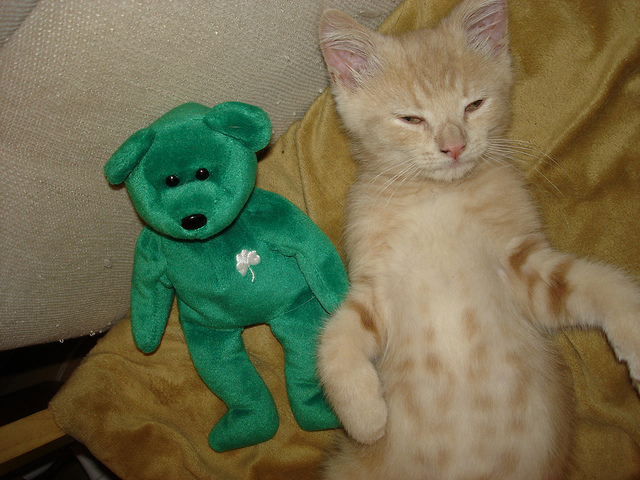<image>What cartoon company do the characters belong to? I don't know which cartoon company the characters belong to. They could belong to Beanie Babies, Disney, or Care Bears. What cartoon company do the characters belong to? I don't know what cartoon company do the characters belong to. It can be either Beanie Babies, Bears, Disney, or Care Bears. 